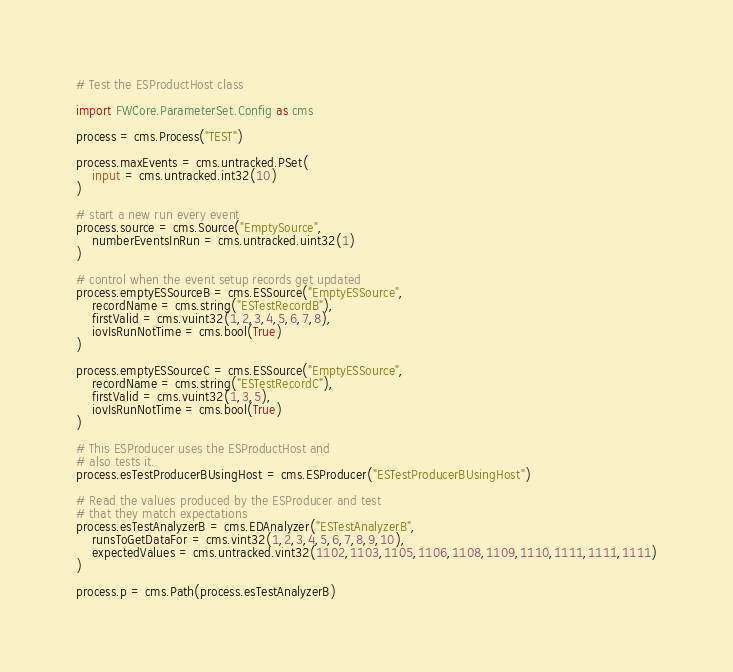<code> <loc_0><loc_0><loc_500><loc_500><_Python_># Test the ESProductHost class

import FWCore.ParameterSet.Config as cms

process = cms.Process("TEST")

process.maxEvents = cms.untracked.PSet(
    input = cms.untracked.int32(10)
)

# start a new run every event
process.source = cms.Source("EmptySource",
    numberEventsInRun = cms.untracked.uint32(1)
)

# control when the event setup records get updated
process.emptyESSourceB = cms.ESSource("EmptyESSource",
    recordName = cms.string("ESTestRecordB"),
    firstValid = cms.vuint32(1,2,3,4,5,6,7,8),
    iovIsRunNotTime = cms.bool(True)
)

process.emptyESSourceC = cms.ESSource("EmptyESSource",
    recordName = cms.string("ESTestRecordC"),
    firstValid = cms.vuint32(1,3,5),
    iovIsRunNotTime = cms.bool(True)
)

# This ESProducer uses the ESProductHost and
# also tests it.
process.esTestProducerBUsingHost = cms.ESProducer("ESTestProducerBUsingHost")

# Read the values produced by the ESProducer and test
# that they match expectations
process.esTestAnalyzerB = cms.EDAnalyzer("ESTestAnalyzerB",
    runsToGetDataFor = cms.vint32(1,2,3,4,5,6,7,8,9,10),
    expectedValues = cms.untracked.vint32(1102,1103,1105,1106,1108,1109,1110,1111,1111,1111)
)

process.p = cms.Path(process.esTestAnalyzerB)
</code> 